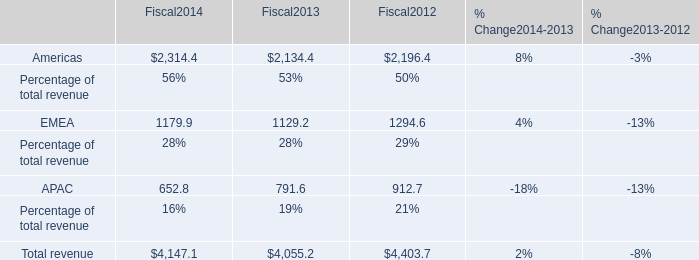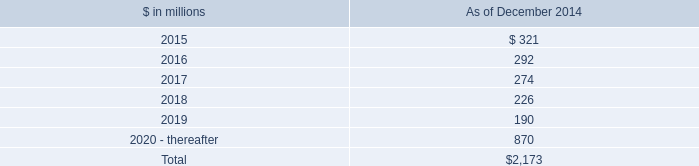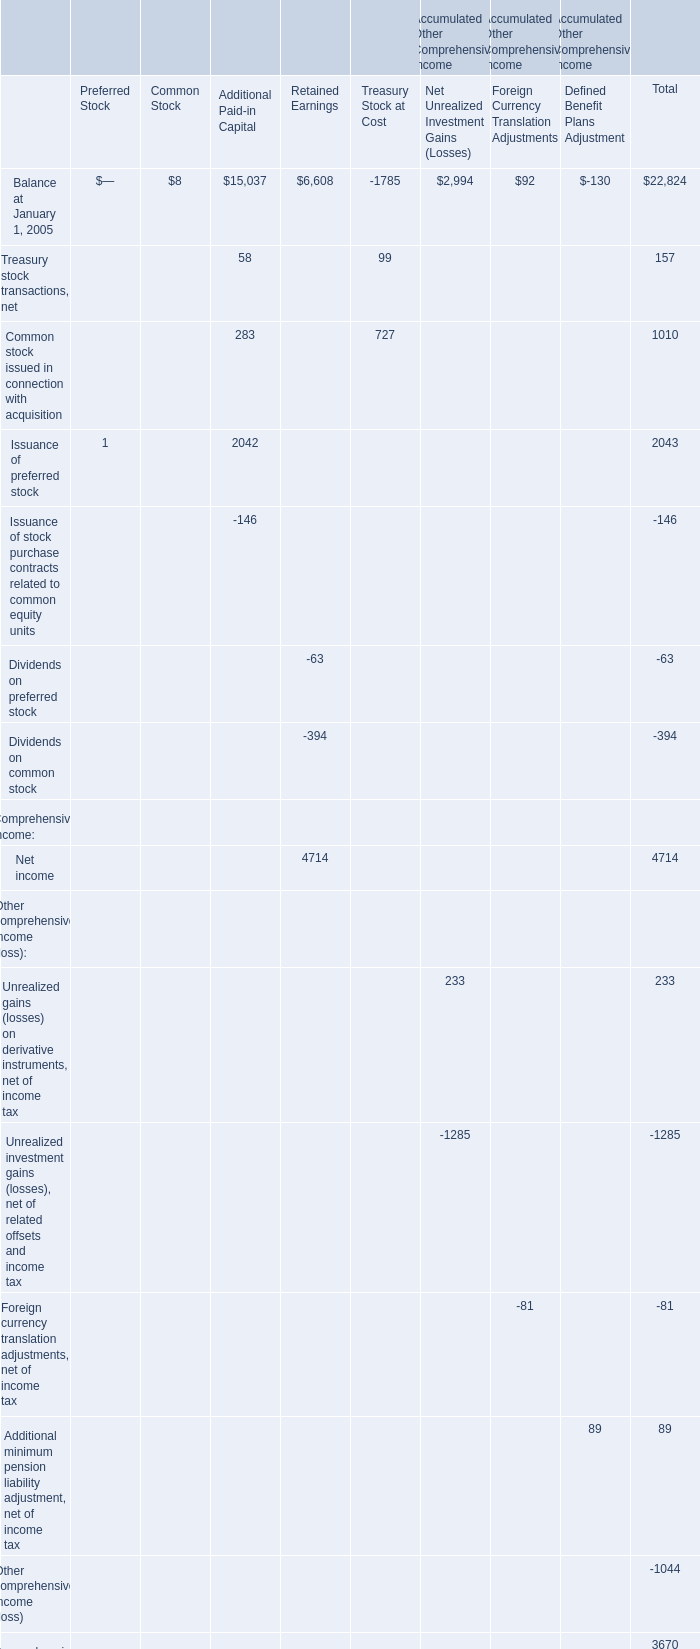rent charged to operating expense in millions totaled how much for 2014 and 2013? 
Computations: (309 + 324)
Answer: 633.0. 